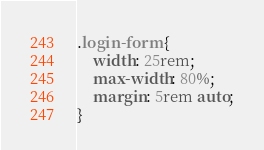Convert code to text. <code><loc_0><loc_0><loc_500><loc_500><_CSS_>.login-form {
    width: 25rem;
    max-width: 80%;
    margin: 5rem auto;
}</code> 